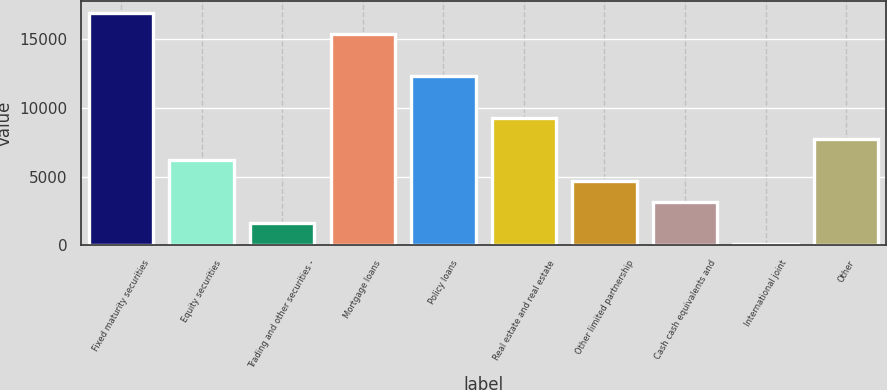Convert chart. <chart><loc_0><loc_0><loc_500><loc_500><bar_chart><fcel>Fixed maturity securities<fcel>Equity securities<fcel>Trading and other securities -<fcel>Mortgage loans<fcel>Policy loans<fcel>Real estate and real estate<fcel>Other limited partnership<fcel>Cash cash equivalents and<fcel>International joint<fcel>Other<nl><fcel>16893.3<fcel>6216.2<fcel>1640.3<fcel>15368<fcel>12317.4<fcel>9266.8<fcel>4690.9<fcel>3165.6<fcel>115<fcel>7741.5<nl></chart> 